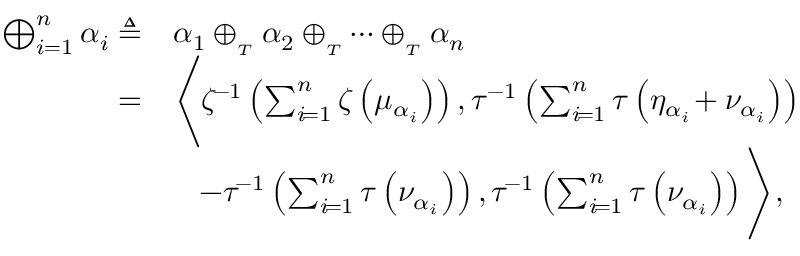<formula> <loc_0><loc_0><loc_500><loc_500>\begin{array} { r l } { \bigoplus _ { i = 1 } ^ { n } \alpha _ { i } \triangle q } & { \alpha _ { 1 } \oplus _ { _ { T } } \alpha _ { 2 } \oplus _ { _ { T } } \cdots \oplus _ { _ { T } } \alpha _ { n } } \\ { = } & { \left \langle \zeta ^ { \, - 1 } \left ( \sum _ { i \, = 1 } ^ { n } \zeta \left ( \mu _ { \alpha _ { i } } \right ) \right ) , \tau ^ { - 1 } \left ( \sum _ { i \, = 1 } ^ { n } \tau \left ( \eta _ { \alpha _ { i } } \, + \nu _ { \alpha _ { i } } \right ) \right ) } \\ & { \quad \, - \tau ^ { \, - 1 } \left ( \sum _ { i \, = 1 } ^ { n } \tau \left ( \nu _ { \alpha _ { i } } \right ) \right ) , \tau ^ { \, - 1 } \left ( \sum _ { i \, = 1 } ^ { n } \tau \left ( \nu _ { \alpha _ { i } } \right ) \right ) \right \rangle , } \end{array}</formula> 